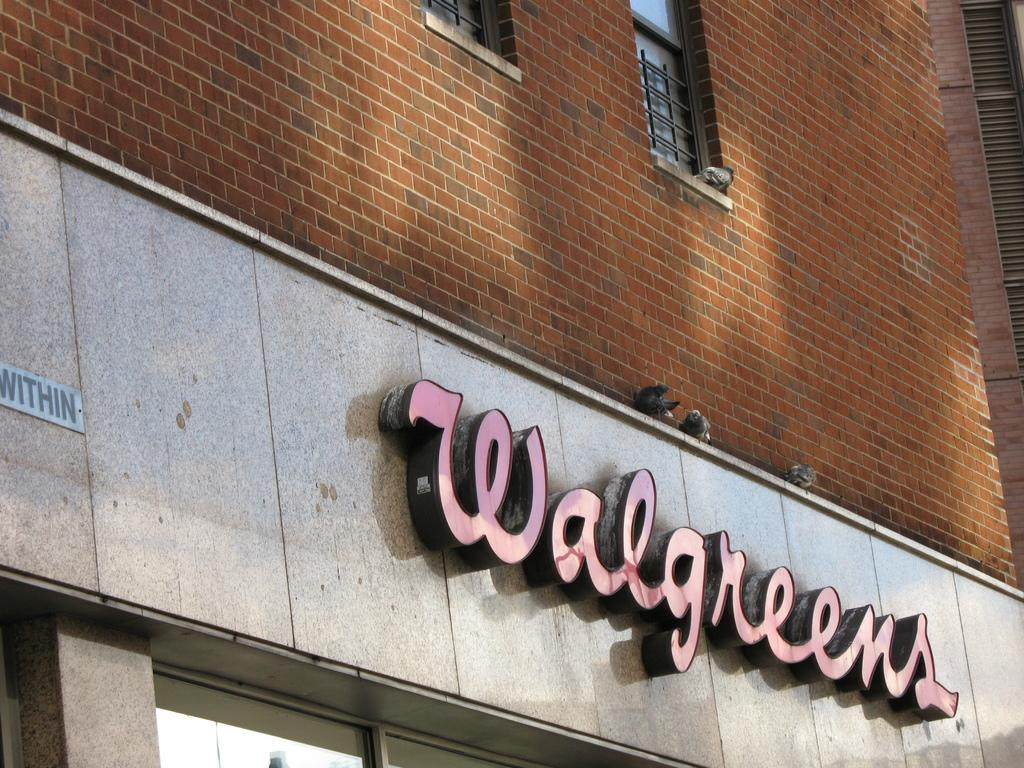Where was the image taken? The image was taken outdoors. What can be seen in the middle of the image? There is a building in the middle of the image. What is on the wall of the building? There is text on the wall of the building. What verse is being recited by the spy in the image? There is no verse or spy present in the image. 